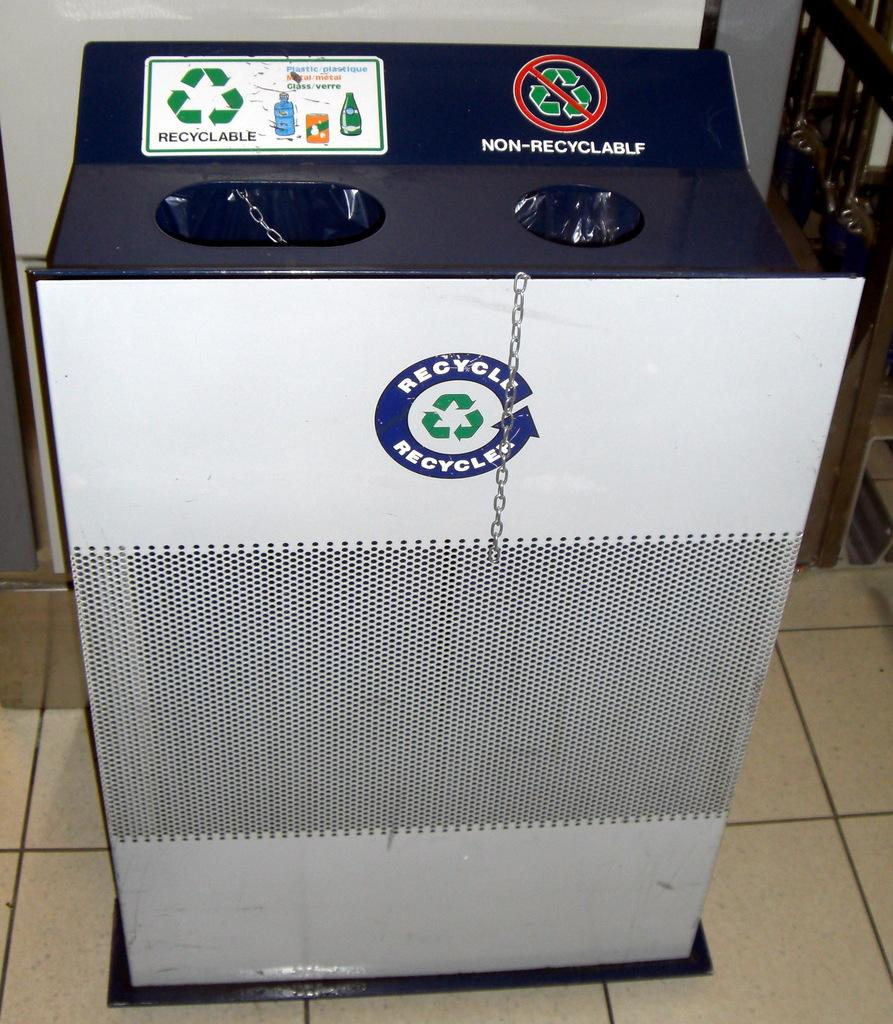Provide a one-sentence caption for the provided image. The recycle bin has a log called Recycle on it. 